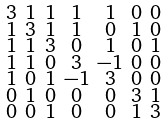Convert formula to latex. <formula><loc_0><loc_0><loc_500><loc_500>\begin{smallmatrix} 3 & 1 & 1 & 1 & 1 & 0 & 0 \\ 1 & 3 & 1 & 1 & 0 & 1 & 0 \\ 1 & 1 & 3 & 0 & 1 & 0 & 1 \\ 1 & 1 & 0 & 3 & - 1 & 0 & 0 \\ 1 & 0 & 1 & - 1 & 3 & 0 & 0 \\ 0 & 1 & 0 & 0 & 0 & 3 & 1 \\ 0 & 0 & 1 & 0 & 0 & 1 & 3 \end{smallmatrix}</formula> 